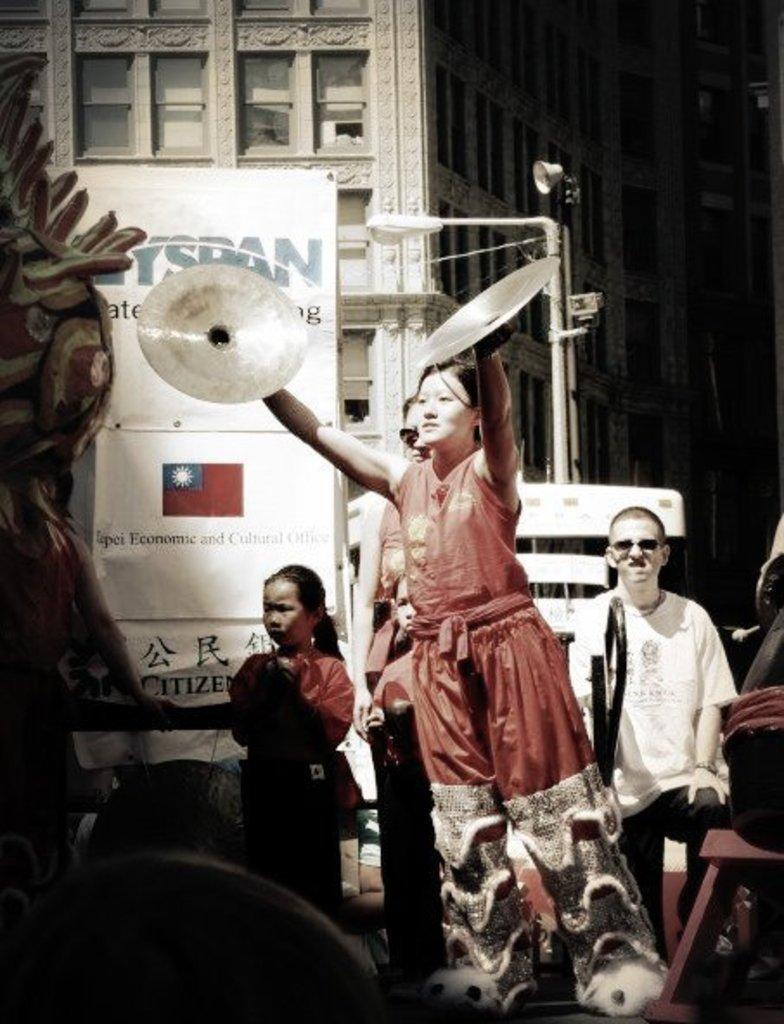How many people are in the image? There are persons in the image, but the exact number is not specified. What is the main object in the image? There is a board in the image. What else can be seen in the image besides the board? There are other objects in the image. What can be seen in the background of the image? There is a building and poles in the background of the image, along with other objects. What type of pin is being used to lift the board in the image? There is no pin or lifting action depicted in the image; the board is simply present. Can you see any guns in the image? There are no guns present in the image. 